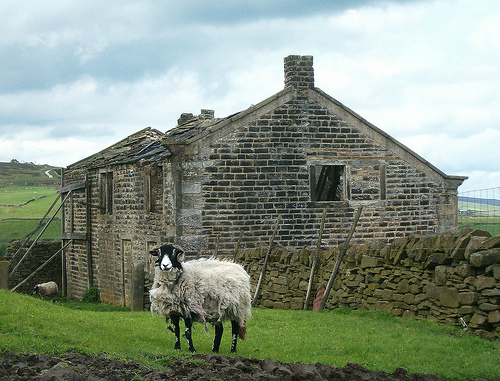<image>
Is there a sheep in the grass? Yes. The sheep is contained within or inside the grass, showing a containment relationship. Is the animal to the left of the building? No. The animal is not to the left of the building. From this viewpoint, they have a different horizontal relationship. 